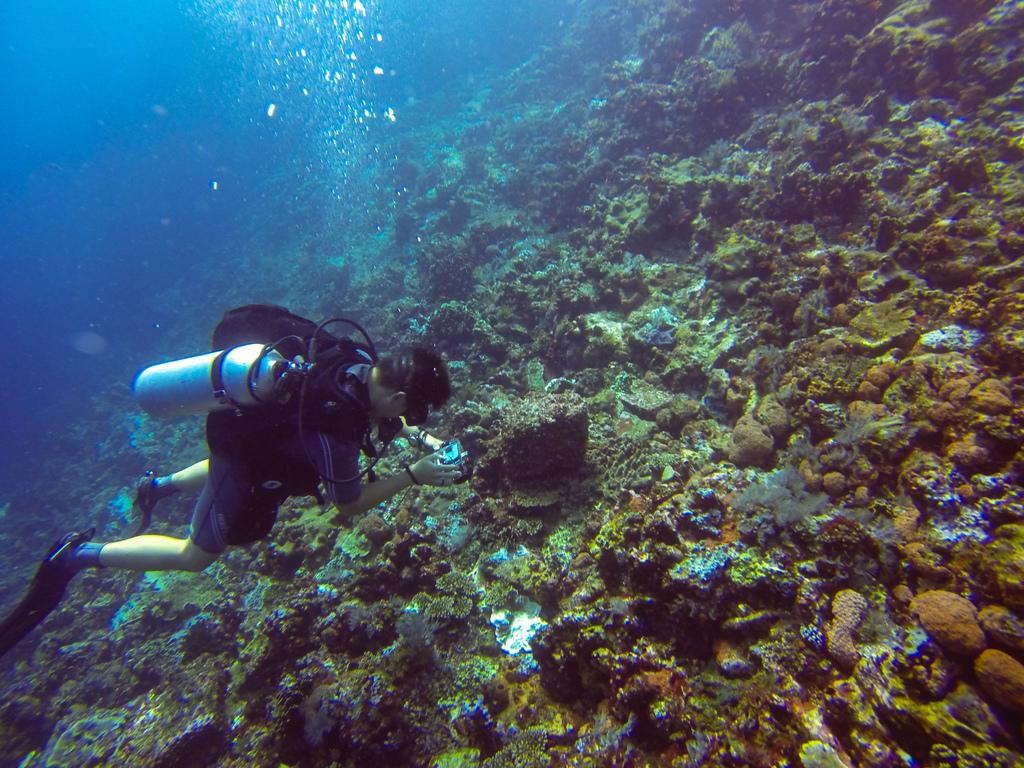Who or what is the main subject of the image? There is a person in the center of the image. What is the person doing or where are they located? The person is underwater. What equipment is the person using? The person has a cylinder on their back. What can be seen in the background of the image? There are stones visible in the background of the image. What type of paper is the sheep using to paste on the wall in the image? There is no paper, sheep, or wall present in the image. 